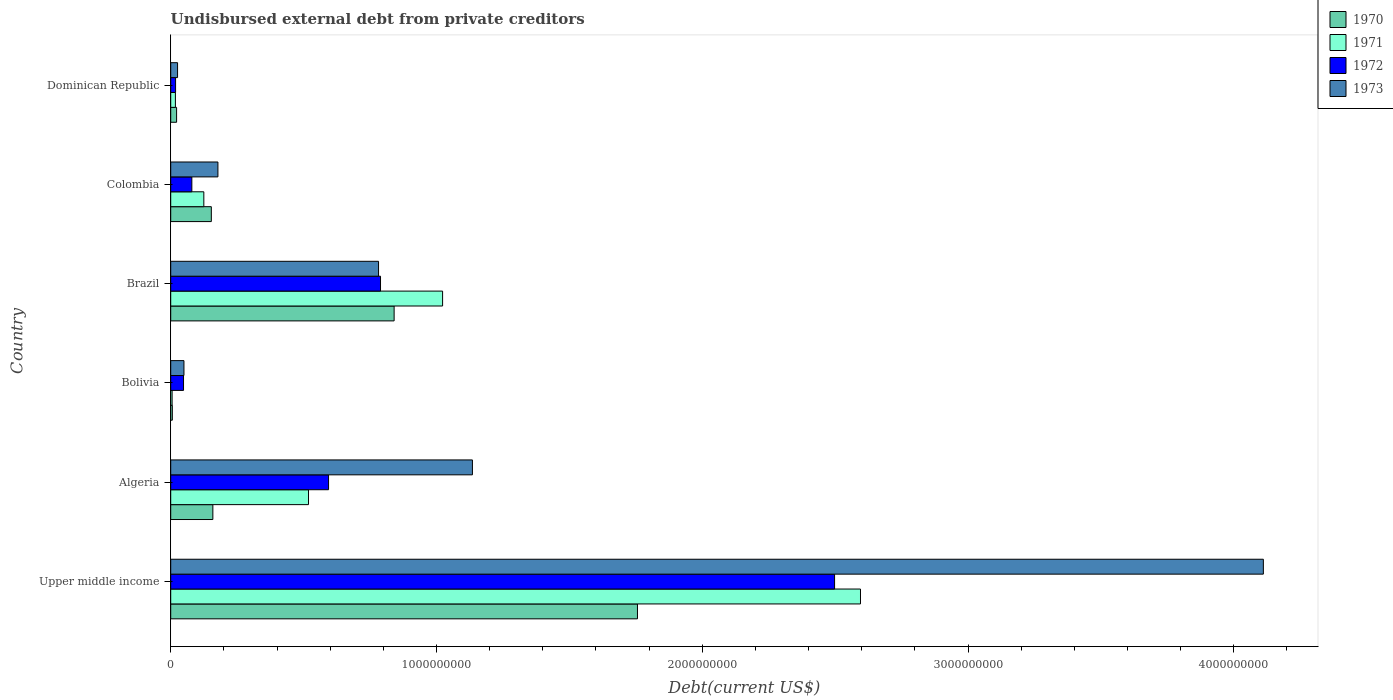How many different coloured bars are there?
Ensure brevity in your answer.  4. How many groups of bars are there?
Provide a succinct answer. 6. Are the number of bars per tick equal to the number of legend labels?
Offer a very short reply. Yes. Are the number of bars on each tick of the Y-axis equal?
Give a very brief answer. Yes. What is the label of the 6th group of bars from the top?
Your response must be concise. Upper middle income. What is the total debt in 1971 in Bolivia?
Your answer should be very brief. 5.25e+06. Across all countries, what is the maximum total debt in 1973?
Keep it short and to the point. 4.11e+09. Across all countries, what is the minimum total debt in 1973?
Provide a succinct answer. 2.58e+07. In which country was the total debt in 1971 maximum?
Ensure brevity in your answer.  Upper middle income. In which country was the total debt in 1972 minimum?
Your answer should be very brief. Dominican Republic. What is the total total debt in 1971 in the graph?
Ensure brevity in your answer.  4.28e+09. What is the difference between the total debt in 1971 in Brazil and that in Colombia?
Offer a terse response. 8.98e+08. What is the difference between the total debt in 1971 in Colombia and the total debt in 1970 in Algeria?
Keep it short and to the point. -3.40e+07. What is the average total debt in 1970 per country?
Offer a very short reply. 4.89e+08. What is the difference between the total debt in 1971 and total debt in 1973 in Brazil?
Keep it short and to the point. 2.41e+08. In how many countries, is the total debt in 1973 greater than 1800000000 US$?
Make the answer very short. 1. What is the ratio of the total debt in 1972 in Dominican Republic to that in Upper middle income?
Your answer should be compact. 0.01. Is the total debt in 1972 in Colombia less than that in Dominican Republic?
Ensure brevity in your answer.  No. What is the difference between the highest and the second highest total debt in 1970?
Offer a very short reply. 9.16e+08. What is the difference between the highest and the lowest total debt in 1973?
Your answer should be very brief. 4.09e+09. In how many countries, is the total debt in 1971 greater than the average total debt in 1971 taken over all countries?
Keep it short and to the point. 2. Is it the case that in every country, the sum of the total debt in 1972 and total debt in 1970 is greater than the sum of total debt in 1971 and total debt in 1973?
Offer a terse response. No. How many bars are there?
Make the answer very short. 24. Are all the bars in the graph horizontal?
Your answer should be compact. Yes. Are the values on the major ticks of X-axis written in scientific E-notation?
Ensure brevity in your answer.  No. Does the graph contain grids?
Keep it short and to the point. No. How many legend labels are there?
Keep it short and to the point. 4. How are the legend labels stacked?
Ensure brevity in your answer.  Vertical. What is the title of the graph?
Offer a very short reply. Undisbursed external debt from private creditors. What is the label or title of the X-axis?
Offer a very short reply. Debt(current US$). What is the Debt(current US$) in 1970 in Upper middle income?
Give a very brief answer. 1.76e+09. What is the Debt(current US$) in 1971 in Upper middle income?
Offer a very short reply. 2.60e+09. What is the Debt(current US$) in 1972 in Upper middle income?
Ensure brevity in your answer.  2.50e+09. What is the Debt(current US$) in 1973 in Upper middle income?
Offer a very short reply. 4.11e+09. What is the Debt(current US$) of 1970 in Algeria?
Provide a succinct answer. 1.59e+08. What is the Debt(current US$) of 1971 in Algeria?
Keep it short and to the point. 5.18e+08. What is the Debt(current US$) in 1972 in Algeria?
Make the answer very short. 5.94e+08. What is the Debt(current US$) in 1973 in Algeria?
Give a very brief answer. 1.14e+09. What is the Debt(current US$) in 1970 in Bolivia?
Your answer should be compact. 6.05e+06. What is the Debt(current US$) of 1971 in Bolivia?
Offer a terse response. 5.25e+06. What is the Debt(current US$) in 1972 in Bolivia?
Your answer should be compact. 4.82e+07. What is the Debt(current US$) of 1973 in Bolivia?
Provide a short and direct response. 4.98e+07. What is the Debt(current US$) of 1970 in Brazil?
Your response must be concise. 8.41e+08. What is the Debt(current US$) of 1971 in Brazil?
Give a very brief answer. 1.02e+09. What is the Debt(current US$) in 1972 in Brazil?
Your response must be concise. 7.89e+08. What is the Debt(current US$) in 1973 in Brazil?
Keep it short and to the point. 7.82e+08. What is the Debt(current US$) of 1970 in Colombia?
Offer a terse response. 1.53e+08. What is the Debt(current US$) in 1971 in Colombia?
Give a very brief answer. 1.25e+08. What is the Debt(current US$) in 1972 in Colombia?
Provide a succinct answer. 7.95e+07. What is the Debt(current US$) in 1973 in Colombia?
Provide a succinct answer. 1.78e+08. What is the Debt(current US$) of 1970 in Dominican Republic?
Give a very brief answer. 2.21e+07. What is the Debt(current US$) of 1971 in Dominican Republic?
Give a very brief answer. 1.76e+07. What is the Debt(current US$) in 1972 in Dominican Republic?
Provide a succinct answer. 1.83e+07. What is the Debt(current US$) of 1973 in Dominican Republic?
Offer a very short reply. 2.58e+07. Across all countries, what is the maximum Debt(current US$) of 1970?
Give a very brief answer. 1.76e+09. Across all countries, what is the maximum Debt(current US$) in 1971?
Give a very brief answer. 2.60e+09. Across all countries, what is the maximum Debt(current US$) of 1972?
Ensure brevity in your answer.  2.50e+09. Across all countries, what is the maximum Debt(current US$) in 1973?
Ensure brevity in your answer.  4.11e+09. Across all countries, what is the minimum Debt(current US$) of 1970?
Ensure brevity in your answer.  6.05e+06. Across all countries, what is the minimum Debt(current US$) of 1971?
Your answer should be very brief. 5.25e+06. Across all countries, what is the minimum Debt(current US$) of 1972?
Make the answer very short. 1.83e+07. Across all countries, what is the minimum Debt(current US$) of 1973?
Keep it short and to the point. 2.58e+07. What is the total Debt(current US$) of 1970 in the graph?
Your answer should be very brief. 2.94e+09. What is the total Debt(current US$) in 1971 in the graph?
Ensure brevity in your answer.  4.28e+09. What is the total Debt(current US$) of 1972 in the graph?
Provide a short and direct response. 4.03e+09. What is the total Debt(current US$) in 1973 in the graph?
Provide a short and direct response. 6.28e+09. What is the difference between the Debt(current US$) in 1970 in Upper middle income and that in Algeria?
Provide a short and direct response. 1.60e+09. What is the difference between the Debt(current US$) of 1971 in Upper middle income and that in Algeria?
Offer a very short reply. 2.08e+09. What is the difference between the Debt(current US$) in 1972 in Upper middle income and that in Algeria?
Provide a succinct answer. 1.90e+09. What is the difference between the Debt(current US$) in 1973 in Upper middle income and that in Algeria?
Your response must be concise. 2.98e+09. What is the difference between the Debt(current US$) in 1970 in Upper middle income and that in Bolivia?
Provide a succinct answer. 1.75e+09. What is the difference between the Debt(current US$) of 1971 in Upper middle income and that in Bolivia?
Offer a terse response. 2.59e+09. What is the difference between the Debt(current US$) in 1972 in Upper middle income and that in Bolivia?
Your answer should be very brief. 2.45e+09. What is the difference between the Debt(current US$) in 1973 in Upper middle income and that in Bolivia?
Give a very brief answer. 4.06e+09. What is the difference between the Debt(current US$) of 1970 in Upper middle income and that in Brazil?
Your answer should be very brief. 9.16e+08. What is the difference between the Debt(current US$) in 1971 in Upper middle income and that in Brazil?
Give a very brief answer. 1.57e+09. What is the difference between the Debt(current US$) in 1972 in Upper middle income and that in Brazil?
Make the answer very short. 1.71e+09. What is the difference between the Debt(current US$) of 1973 in Upper middle income and that in Brazil?
Your response must be concise. 3.33e+09. What is the difference between the Debt(current US$) of 1970 in Upper middle income and that in Colombia?
Offer a terse response. 1.60e+09. What is the difference between the Debt(current US$) of 1971 in Upper middle income and that in Colombia?
Make the answer very short. 2.47e+09. What is the difference between the Debt(current US$) of 1972 in Upper middle income and that in Colombia?
Keep it short and to the point. 2.42e+09. What is the difference between the Debt(current US$) of 1973 in Upper middle income and that in Colombia?
Your answer should be very brief. 3.93e+09. What is the difference between the Debt(current US$) in 1970 in Upper middle income and that in Dominican Republic?
Provide a short and direct response. 1.73e+09. What is the difference between the Debt(current US$) in 1971 in Upper middle income and that in Dominican Republic?
Your response must be concise. 2.58e+09. What is the difference between the Debt(current US$) of 1972 in Upper middle income and that in Dominican Republic?
Offer a terse response. 2.48e+09. What is the difference between the Debt(current US$) of 1973 in Upper middle income and that in Dominican Republic?
Give a very brief answer. 4.09e+09. What is the difference between the Debt(current US$) in 1970 in Algeria and that in Bolivia?
Offer a terse response. 1.53e+08. What is the difference between the Debt(current US$) in 1971 in Algeria and that in Bolivia?
Provide a short and direct response. 5.13e+08. What is the difference between the Debt(current US$) in 1972 in Algeria and that in Bolivia?
Give a very brief answer. 5.46e+08. What is the difference between the Debt(current US$) of 1973 in Algeria and that in Bolivia?
Provide a succinct answer. 1.09e+09. What is the difference between the Debt(current US$) of 1970 in Algeria and that in Brazil?
Offer a very short reply. -6.82e+08. What is the difference between the Debt(current US$) of 1971 in Algeria and that in Brazil?
Keep it short and to the point. -5.05e+08. What is the difference between the Debt(current US$) in 1972 in Algeria and that in Brazil?
Provide a short and direct response. -1.95e+08. What is the difference between the Debt(current US$) of 1973 in Algeria and that in Brazil?
Provide a short and direct response. 3.53e+08. What is the difference between the Debt(current US$) of 1970 in Algeria and that in Colombia?
Your answer should be very brief. 5.77e+06. What is the difference between the Debt(current US$) in 1971 in Algeria and that in Colombia?
Offer a very short reply. 3.94e+08. What is the difference between the Debt(current US$) in 1972 in Algeria and that in Colombia?
Your response must be concise. 5.14e+08. What is the difference between the Debt(current US$) in 1973 in Algeria and that in Colombia?
Your response must be concise. 9.58e+08. What is the difference between the Debt(current US$) of 1970 in Algeria and that in Dominican Republic?
Your response must be concise. 1.36e+08. What is the difference between the Debt(current US$) in 1971 in Algeria and that in Dominican Republic?
Make the answer very short. 5.01e+08. What is the difference between the Debt(current US$) in 1972 in Algeria and that in Dominican Republic?
Your answer should be very brief. 5.76e+08. What is the difference between the Debt(current US$) in 1973 in Algeria and that in Dominican Republic?
Keep it short and to the point. 1.11e+09. What is the difference between the Debt(current US$) in 1970 in Bolivia and that in Brazil?
Provide a succinct answer. -8.35e+08. What is the difference between the Debt(current US$) of 1971 in Bolivia and that in Brazil?
Offer a terse response. -1.02e+09. What is the difference between the Debt(current US$) in 1972 in Bolivia and that in Brazil?
Give a very brief answer. -7.41e+08. What is the difference between the Debt(current US$) of 1973 in Bolivia and that in Brazil?
Offer a very short reply. -7.32e+08. What is the difference between the Debt(current US$) in 1970 in Bolivia and that in Colombia?
Your answer should be compact. -1.47e+08. What is the difference between the Debt(current US$) of 1971 in Bolivia and that in Colombia?
Provide a succinct answer. -1.19e+08. What is the difference between the Debt(current US$) of 1972 in Bolivia and that in Colombia?
Your response must be concise. -3.13e+07. What is the difference between the Debt(current US$) of 1973 in Bolivia and that in Colombia?
Your response must be concise. -1.28e+08. What is the difference between the Debt(current US$) of 1970 in Bolivia and that in Dominican Republic?
Provide a succinct answer. -1.60e+07. What is the difference between the Debt(current US$) of 1971 in Bolivia and that in Dominican Republic?
Offer a terse response. -1.24e+07. What is the difference between the Debt(current US$) of 1972 in Bolivia and that in Dominican Republic?
Give a very brief answer. 2.99e+07. What is the difference between the Debt(current US$) of 1973 in Bolivia and that in Dominican Republic?
Keep it short and to the point. 2.40e+07. What is the difference between the Debt(current US$) of 1970 in Brazil and that in Colombia?
Offer a terse response. 6.88e+08. What is the difference between the Debt(current US$) of 1971 in Brazil and that in Colombia?
Provide a succinct answer. 8.98e+08. What is the difference between the Debt(current US$) in 1972 in Brazil and that in Colombia?
Offer a terse response. 7.10e+08. What is the difference between the Debt(current US$) in 1973 in Brazil and that in Colombia?
Offer a terse response. 6.04e+08. What is the difference between the Debt(current US$) of 1970 in Brazil and that in Dominican Republic?
Provide a succinct answer. 8.19e+08. What is the difference between the Debt(current US$) of 1971 in Brazil and that in Dominican Republic?
Offer a terse response. 1.01e+09. What is the difference between the Debt(current US$) in 1972 in Brazil and that in Dominican Republic?
Ensure brevity in your answer.  7.71e+08. What is the difference between the Debt(current US$) of 1973 in Brazil and that in Dominican Republic?
Provide a succinct answer. 7.56e+08. What is the difference between the Debt(current US$) of 1970 in Colombia and that in Dominican Republic?
Your response must be concise. 1.31e+08. What is the difference between the Debt(current US$) in 1971 in Colombia and that in Dominican Republic?
Your response must be concise. 1.07e+08. What is the difference between the Debt(current US$) of 1972 in Colombia and that in Dominican Republic?
Offer a terse response. 6.12e+07. What is the difference between the Debt(current US$) in 1973 in Colombia and that in Dominican Republic?
Make the answer very short. 1.52e+08. What is the difference between the Debt(current US$) in 1970 in Upper middle income and the Debt(current US$) in 1971 in Algeria?
Your response must be concise. 1.24e+09. What is the difference between the Debt(current US$) in 1970 in Upper middle income and the Debt(current US$) in 1972 in Algeria?
Give a very brief answer. 1.16e+09. What is the difference between the Debt(current US$) of 1970 in Upper middle income and the Debt(current US$) of 1973 in Algeria?
Offer a very short reply. 6.21e+08. What is the difference between the Debt(current US$) in 1971 in Upper middle income and the Debt(current US$) in 1972 in Algeria?
Your response must be concise. 2.00e+09. What is the difference between the Debt(current US$) in 1971 in Upper middle income and the Debt(current US$) in 1973 in Algeria?
Offer a terse response. 1.46e+09. What is the difference between the Debt(current US$) in 1972 in Upper middle income and the Debt(current US$) in 1973 in Algeria?
Keep it short and to the point. 1.36e+09. What is the difference between the Debt(current US$) in 1970 in Upper middle income and the Debt(current US$) in 1971 in Bolivia?
Provide a short and direct response. 1.75e+09. What is the difference between the Debt(current US$) of 1970 in Upper middle income and the Debt(current US$) of 1972 in Bolivia?
Your response must be concise. 1.71e+09. What is the difference between the Debt(current US$) in 1970 in Upper middle income and the Debt(current US$) in 1973 in Bolivia?
Give a very brief answer. 1.71e+09. What is the difference between the Debt(current US$) of 1971 in Upper middle income and the Debt(current US$) of 1972 in Bolivia?
Offer a terse response. 2.55e+09. What is the difference between the Debt(current US$) of 1971 in Upper middle income and the Debt(current US$) of 1973 in Bolivia?
Your response must be concise. 2.55e+09. What is the difference between the Debt(current US$) of 1972 in Upper middle income and the Debt(current US$) of 1973 in Bolivia?
Give a very brief answer. 2.45e+09. What is the difference between the Debt(current US$) in 1970 in Upper middle income and the Debt(current US$) in 1971 in Brazil?
Keep it short and to the point. 7.33e+08. What is the difference between the Debt(current US$) of 1970 in Upper middle income and the Debt(current US$) of 1972 in Brazil?
Your response must be concise. 9.67e+08. What is the difference between the Debt(current US$) of 1970 in Upper middle income and the Debt(current US$) of 1973 in Brazil?
Give a very brief answer. 9.74e+08. What is the difference between the Debt(current US$) of 1971 in Upper middle income and the Debt(current US$) of 1972 in Brazil?
Offer a very short reply. 1.81e+09. What is the difference between the Debt(current US$) of 1971 in Upper middle income and the Debt(current US$) of 1973 in Brazil?
Give a very brief answer. 1.81e+09. What is the difference between the Debt(current US$) of 1972 in Upper middle income and the Debt(current US$) of 1973 in Brazil?
Keep it short and to the point. 1.72e+09. What is the difference between the Debt(current US$) of 1970 in Upper middle income and the Debt(current US$) of 1971 in Colombia?
Your response must be concise. 1.63e+09. What is the difference between the Debt(current US$) in 1970 in Upper middle income and the Debt(current US$) in 1972 in Colombia?
Keep it short and to the point. 1.68e+09. What is the difference between the Debt(current US$) of 1970 in Upper middle income and the Debt(current US$) of 1973 in Colombia?
Offer a very short reply. 1.58e+09. What is the difference between the Debt(current US$) of 1971 in Upper middle income and the Debt(current US$) of 1972 in Colombia?
Your answer should be very brief. 2.52e+09. What is the difference between the Debt(current US$) in 1971 in Upper middle income and the Debt(current US$) in 1973 in Colombia?
Your response must be concise. 2.42e+09. What is the difference between the Debt(current US$) in 1972 in Upper middle income and the Debt(current US$) in 1973 in Colombia?
Offer a terse response. 2.32e+09. What is the difference between the Debt(current US$) of 1970 in Upper middle income and the Debt(current US$) of 1971 in Dominican Republic?
Your answer should be very brief. 1.74e+09. What is the difference between the Debt(current US$) in 1970 in Upper middle income and the Debt(current US$) in 1972 in Dominican Republic?
Provide a short and direct response. 1.74e+09. What is the difference between the Debt(current US$) of 1970 in Upper middle income and the Debt(current US$) of 1973 in Dominican Republic?
Ensure brevity in your answer.  1.73e+09. What is the difference between the Debt(current US$) of 1971 in Upper middle income and the Debt(current US$) of 1972 in Dominican Republic?
Provide a succinct answer. 2.58e+09. What is the difference between the Debt(current US$) of 1971 in Upper middle income and the Debt(current US$) of 1973 in Dominican Republic?
Ensure brevity in your answer.  2.57e+09. What is the difference between the Debt(current US$) of 1972 in Upper middle income and the Debt(current US$) of 1973 in Dominican Republic?
Offer a terse response. 2.47e+09. What is the difference between the Debt(current US$) in 1970 in Algeria and the Debt(current US$) in 1971 in Bolivia?
Keep it short and to the point. 1.53e+08. What is the difference between the Debt(current US$) in 1970 in Algeria and the Debt(current US$) in 1972 in Bolivia?
Offer a very short reply. 1.10e+08. What is the difference between the Debt(current US$) in 1970 in Algeria and the Debt(current US$) in 1973 in Bolivia?
Provide a succinct answer. 1.09e+08. What is the difference between the Debt(current US$) of 1971 in Algeria and the Debt(current US$) of 1972 in Bolivia?
Keep it short and to the point. 4.70e+08. What is the difference between the Debt(current US$) of 1971 in Algeria and the Debt(current US$) of 1973 in Bolivia?
Make the answer very short. 4.69e+08. What is the difference between the Debt(current US$) of 1972 in Algeria and the Debt(current US$) of 1973 in Bolivia?
Keep it short and to the point. 5.44e+08. What is the difference between the Debt(current US$) in 1970 in Algeria and the Debt(current US$) in 1971 in Brazil?
Provide a succinct answer. -8.64e+08. What is the difference between the Debt(current US$) in 1970 in Algeria and the Debt(current US$) in 1972 in Brazil?
Provide a succinct answer. -6.31e+08. What is the difference between the Debt(current US$) of 1970 in Algeria and the Debt(current US$) of 1973 in Brazil?
Your answer should be compact. -6.23e+08. What is the difference between the Debt(current US$) of 1971 in Algeria and the Debt(current US$) of 1972 in Brazil?
Provide a short and direct response. -2.71e+08. What is the difference between the Debt(current US$) of 1971 in Algeria and the Debt(current US$) of 1973 in Brazil?
Provide a short and direct response. -2.64e+08. What is the difference between the Debt(current US$) of 1972 in Algeria and the Debt(current US$) of 1973 in Brazil?
Your response must be concise. -1.88e+08. What is the difference between the Debt(current US$) in 1970 in Algeria and the Debt(current US$) in 1971 in Colombia?
Make the answer very short. 3.40e+07. What is the difference between the Debt(current US$) in 1970 in Algeria and the Debt(current US$) in 1972 in Colombia?
Keep it short and to the point. 7.91e+07. What is the difference between the Debt(current US$) of 1970 in Algeria and the Debt(current US$) of 1973 in Colombia?
Provide a short and direct response. -1.90e+07. What is the difference between the Debt(current US$) in 1971 in Algeria and the Debt(current US$) in 1972 in Colombia?
Your answer should be compact. 4.39e+08. What is the difference between the Debt(current US$) in 1971 in Algeria and the Debt(current US$) in 1973 in Colombia?
Your answer should be very brief. 3.41e+08. What is the difference between the Debt(current US$) of 1972 in Algeria and the Debt(current US$) of 1973 in Colombia?
Offer a terse response. 4.16e+08. What is the difference between the Debt(current US$) in 1970 in Algeria and the Debt(current US$) in 1971 in Dominican Republic?
Your answer should be compact. 1.41e+08. What is the difference between the Debt(current US$) of 1970 in Algeria and the Debt(current US$) of 1972 in Dominican Republic?
Keep it short and to the point. 1.40e+08. What is the difference between the Debt(current US$) in 1970 in Algeria and the Debt(current US$) in 1973 in Dominican Republic?
Keep it short and to the point. 1.33e+08. What is the difference between the Debt(current US$) of 1971 in Algeria and the Debt(current US$) of 1972 in Dominican Republic?
Your answer should be compact. 5.00e+08. What is the difference between the Debt(current US$) of 1971 in Algeria and the Debt(current US$) of 1973 in Dominican Republic?
Give a very brief answer. 4.93e+08. What is the difference between the Debt(current US$) of 1972 in Algeria and the Debt(current US$) of 1973 in Dominican Republic?
Your answer should be compact. 5.68e+08. What is the difference between the Debt(current US$) of 1970 in Bolivia and the Debt(current US$) of 1971 in Brazil?
Make the answer very short. -1.02e+09. What is the difference between the Debt(current US$) in 1970 in Bolivia and the Debt(current US$) in 1972 in Brazil?
Offer a very short reply. -7.83e+08. What is the difference between the Debt(current US$) of 1970 in Bolivia and the Debt(current US$) of 1973 in Brazil?
Ensure brevity in your answer.  -7.76e+08. What is the difference between the Debt(current US$) in 1971 in Bolivia and the Debt(current US$) in 1972 in Brazil?
Make the answer very short. -7.84e+08. What is the difference between the Debt(current US$) in 1971 in Bolivia and the Debt(current US$) in 1973 in Brazil?
Provide a succinct answer. -7.77e+08. What is the difference between the Debt(current US$) in 1972 in Bolivia and the Debt(current US$) in 1973 in Brazil?
Offer a very short reply. -7.34e+08. What is the difference between the Debt(current US$) of 1970 in Bolivia and the Debt(current US$) of 1971 in Colombia?
Offer a terse response. -1.19e+08. What is the difference between the Debt(current US$) of 1970 in Bolivia and the Debt(current US$) of 1972 in Colombia?
Provide a short and direct response. -7.34e+07. What is the difference between the Debt(current US$) in 1970 in Bolivia and the Debt(current US$) in 1973 in Colombia?
Provide a succinct answer. -1.72e+08. What is the difference between the Debt(current US$) in 1971 in Bolivia and the Debt(current US$) in 1972 in Colombia?
Make the answer very short. -7.42e+07. What is the difference between the Debt(current US$) of 1971 in Bolivia and the Debt(current US$) of 1973 in Colombia?
Ensure brevity in your answer.  -1.72e+08. What is the difference between the Debt(current US$) of 1972 in Bolivia and the Debt(current US$) of 1973 in Colombia?
Provide a succinct answer. -1.29e+08. What is the difference between the Debt(current US$) of 1970 in Bolivia and the Debt(current US$) of 1971 in Dominican Republic?
Give a very brief answer. -1.16e+07. What is the difference between the Debt(current US$) of 1970 in Bolivia and the Debt(current US$) of 1972 in Dominican Republic?
Give a very brief answer. -1.23e+07. What is the difference between the Debt(current US$) of 1970 in Bolivia and the Debt(current US$) of 1973 in Dominican Republic?
Give a very brief answer. -1.97e+07. What is the difference between the Debt(current US$) in 1971 in Bolivia and the Debt(current US$) in 1972 in Dominican Republic?
Make the answer very short. -1.31e+07. What is the difference between the Debt(current US$) of 1971 in Bolivia and the Debt(current US$) of 1973 in Dominican Republic?
Provide a short and direct response. -2.05e+07. What is the difference between the Debt(current US$) of 1972 in Bolivia and the Debt(current US$) of 1973 in Dominican Republic?
Give a very brief answer. 2.24e+07. What is the difference between the Debt(current US$) in 1970 in Brazil and the Debt(current US$) in 1971 in Colombia?
Offer a very short reply. 7.16e+08. What is the difference between the Debt(current US$) in 1970 in Brazil and the Debt(current US$) in 1972 in Colombia?
Offer a very short reply. 7.61e+08. What is the difference between the Debt(current US$) of 1970 in Brazil and the Debt(current US$) of 1973 in Colombia?
Keep it short and to the point. 6.63e+08. What is the difference between the Debt(current US$) in 1971 in Brazil and the Debt(current US$) in 1972 in Colombia?
Offer a terse response. 9.44e+08. What is the difference between the Debt(current US$) of 1971 in Brazil and the Debt(current US$) of 1973 in Colombia?
Provide a short and direct response. 8.45e+08. What is the difference between the Debt(current US$) in 1972 in Brazil and the Debt(current US$) in 1973 in Colombia?
Keep it short and to the point. 6.12e+08. What is the difference between the Debt(current US$) in 1970 in Brazil and the Debt(current US$) in 1971 in Dominican Republic?
Provide a succinct answer. 8.23e+08. What is the difference between the Debt(current US$) in 1970 in Brazil and the Debt(current US$) in 1972 in Dominican Republic?
Ensure brevity in your answer.  8.22e+08. What is the difference between the Debt(current US$) of 1970 in Brazil and the Debt(current US$) of 1973 in Dominican Republic?
Provide a succinct answer. 8.15e+08. What is the difference between the Debt(current US$) in 1971 in Brazil and the Debt(current US$) in 1972 in Dominican Republic?
Offer a terse response. 1.00e+09. What is the difference between the Debt(current US$) in 1971 in Brazil and the Debt(current US$) in 1973 in Dominican Republic?
Your response must be concise. 9.97e+08. What is the difference between the Debt(current US$) of 1972 in Brazil and the Debt(current US$) of 1973 in Dominican Republic?
Ensure brevity in your answer.  7.64e+08. What is the difference between the Debt(current US$) of 1970 in Colombia and the Debt(current US$) of 1971 in Dominican Republic?
Your answer should be compact. 1.35e+08. What is the difference between the Debt(current US$) in 1970 in Colombia and the Debt(current US$) in 1972 in Dominican Republic?
Provide a succinct answer. 1.34e+08. What is the difference between the Debt(current US$) of 1970 in Colombia and the Debt(current US$) of 1973 in Dominican Republic?
Offer a very short reply. 1.27e+08. What is the difference between the Debt(current US$) of 1971 in Colombia and the Debt(current US$) of 1972 in Dominican Republic?
Provide a succinct answer. 1.06e+08. What is the difference between the Debt(current US$) of 1971 in Colombia and the Debt(current US$) of 1973 in Dominican Republic?
Make the answer very short. 9.88e+07. What is the difference between the Debt(current US$) of 1972 in Colombia and the Debt(current US$) of 1973 in Dominican Republic?
Offer a terse response. 5.37e+07. What is the average Debt(current US$) in 1970 per country?
Your answer should be very brief. 4.89e+08. What is the average Debt(current US$) of 1971 per country?
Offer a terse response. 7.14e+08. What is the average Debt(current US$) of 1972 per country?
Offer a very short reply. 6.71e+08. What is the average Debt(current US$) of 1973 per country?
Offer a terse response. 1.05e+09. What is the difference between the Debt(current US$) of 1970 and Debt(current US$) of 1971 in Upper middle income?
Your answer should be compact. -8.39e+08. What is the difference between the Debt(current US$) in 1970 and Debt(current US$) in 1972 in Upper middle income?
Your response must be concise. -7.42e+08. What is the difference between the Debt(current US$) in 1970 and Debt(current US$) in 1973 in Upper middle income?
Keep it short and to the point. -2.36e+09. What is the difference between the Debt(current US$) in 1971 and Debt(current US$) in 1972 in Upper middle income?
Your answer should be compact. 9.75e+07. What is the difference between the Debt(current US$) of 1971 and Debt(current US$) of 1973 in Upper middle income?
Provide a short and direct response. -1.52e+09. What is the difference between the Debt(current US$) in 1972 and Debt(current US$) in 1973 in Upper middle income?
Provide a succinct answer. -1.61e+09. What is the difference between the Debt(current US$) of 1970 and Debt(current US$) of 1971 in Algeria?
Ensure brevity in your answer.  -3.60e+08. What is the difference between the Debt(current US$) in 1970 and Debt(current US$) in 1972 in Algeria?
Keep it short and to the point. -4.35e+08. What is the difference between the Debt(current US$) in 1970 and Debt(current US$) in 1973 in Algeria?
Ensure brevity in your answer.  -9.77e+08. What is the difference between the Debt(current US$) in 1971 and Debt(current US$) in 1972 in Algeria?
Your answer should be very brief. -7.55e+07. What is the difference between the Debt(current US$) in 1971 and Debt(current US$) in 1973 in Algeria?
Ensure brevity in your answer.  -6.17e+08. What is the difference between the Debt(current US$) in 1972 and Debt(current US$) in 1973 in Algeria?
Offer a terse response. -5.41e+08. What is the difference between the Debt(current US$) of 1970 and Debt(current US$) of 1971 in Bolivia?
Offer a very short reply. 8.02e+05. What is the difference between the Debt(current US$) of 1970 and Debt(current US$) of 1972 in Bolivia?
Your answer should be very brief. -4.22e+07. What is the difference between the Debt(current US$) in 1970 and Debt(current US$) in 1973 in Bolivia?
Offer a very short reply. -4.37e+07. What is the difference between the Debt(current US$) of 1971 and Debt(current US$) of 1972 in Bolivia?
Provide a succinct answer. -4.30e+07. What is the difference between the Debt(current US$) in 1971 and Debt(current US$) in 1973 in Bolivia?
Keep it short and to the point. -4.45e+07. What is the difference between the Debt(current US$) of 1972 and Debt(current US$) of 1973 in Bolivia?
Provide a succinct answer. -1.58e+06. What is the difference between the Debt(current US$) of 1970 and Debt(current US$) of 1971 in Brazil?
Offer a very short reply. -1.82e+08. What is the difference between the Debt(current US$) of 1970 and Debt(current US$) of 1972 in Brazil?
Provide a short and direct response. 5.12e+07. What is the difference between the Debt(current US$) of 1970 and Debt(current US$) of 1973 in Brazil?
Your answer should be compact. 5.86e+07. What is the difference between the Debt(current US$) in 1971 and Debt(current US$) in 1972 in Brazil?
Your response must be concise. 2.34e+08. What is the difference between the Debt(current US$) in 1971 and Debt(current US$) in 1973 in Brazil?
Keep it short and to the point. 2.41e+08. What is the difference between the Debt(current US$) in 1972 and Debt(current US$) in 1973 in Brazil?
Give a very brief answer. 7.41e+06. What is the difference between the Debt(current US$) of 1970 and Debt(current US$) of 1971 in Colombia?
Offer a very short reply. 2.82e+07. What is the difference between the Debt(current US$) in 1970 and Debt(current US$) in 1972 in Colombia?
Provide a short and direct response. 7.33e+07. What is the difference between the Debt(current US$) of 1970 and Debt(current US$) of 1973 in Colombia?
Keep it short and to the point. -2.48e+07. What is the difference between the Debt(current US$) in 1971 and Debt(current US$) in 1972 in Colombia?
Give a very brief answer. 4.51e+07. What is the difference between the Debt(current US$) in 1971 and Debt(current US$) in 1973 in Colombia?
Ensure brevity in your answer.  -5.30e+07. What is the difference between the Debt(current US$) of 1972 and Debt(current US$) of 1973 in Colombia?
Offer a terse response. -9.81e+07. What is the difference between the Debt(current US$) of 1970 and Debt(current US$) of 1971 in Dominican Republic?
Your answer should be compact. 4.46e+06. What is the difference between the Debt(current US$) in 1970 and Debt(current US$) in 1972 in Dominican Republic?
Your answer should be compact. 3.78e+06. What is the difference between the Debt(current US$) of 1970 and Debt(current US$) of 1973 in Dominican Republic?
Your answer should be compact. -3.68e+06. What is the difference between the Debt(current US$) of 1971 and Debt(current US$) of 1972 in Dominican Republic?
Provide a short and direct response. -6.84e+05. What is the difference between the Debt(current US$) of 1971 and Debt(current US$) of 1973 in Dominican Republic?
Ensure brevity in your answer.  -8.14e+06. What is the difference between the Debt(current US$) of 1972 and Debt(current US$) of 1973 in Dominican Republic?
Provide a succinct answer. -7.46e+06. What is the ratio of the Debt(current US$) of 1970 in Upper middle income to that in Algeria?
Your response must be concise. 11.08. What is the ratio of the Debt(current US$) in 1971 in Upper middle income to that in Algeria?
Keep it short and to the point. 5.01. What is the ratio of the Debt(current US$) of 1972 in Upper middle income to that in Algeria?
Your answer should be compact. 4.21. What is the ratio of the Debt(current US$) in 1973 in Upper middle income to that in Algeria?
Your answer should be compact. 3.62. What is the ratio of the Debt(current US$) in 1970 in Upper middle income to that in Bolivia?
Your answer should be compact. 290.38. What is the ratio of the Debt(current US$) of 1971 in Upper middle income to that in Bolivia?
Your response must be concise. 494.74. What is the ratio of the Debt(current US$) of 1972 in Upper middle income to that in Bolivia?
Provide a succinct answer. 51.81. What is the ratio of the Debt(current US$) in 1973 in Upper middle income to that in Bolivia?
Your response must be concise. 82.58. What is the ratio of the Debt(current US$) in 1970 in Upper middle income to that in Brazil?
Your answer should be compact. 2.09. What is the ratio of the Debt(current US$) of 1971 in Upper middle income to that in Brazil?
Provide a succinct answer. 2.54. What is the ratio of the Debt(current US$) in 1972 in Upper middle income to that in Brazil?
Keep it short and to the point. 3.16. What is the ratio of the Debt(current US$) of 1973 in Upper middle income to that in Brazil?
Give a very brief answer. 5.26. What is the ratio of the Debt(current US$) of 1970 in Upper middle income to that in Colombia?
Keep it short and to the point. 11.49. What is the ratio of the Debt(current US$) of 1971 in Upper middle income to that in Colombia?
Make the answer very short. 20.83. What is the ratio of the Debt(current US$) of 1972 in Upper middle income to that in Colombia?
Keep it short and to the point. 31.43. What is the ratio of the Debt(current US$) in 1973 in Upper middle income to that in Colombia?
Your answer should be very brief. 23.15. What is the ratio of the Debt(current US$) of 1970 in Upper middle income to that in Dominican Republic?
Make the answer very short. 79.48. What is the ratio of the Debt(current US$) in 1971 in Upper middle income to that in Dominican Republic?
Ensure brevity in your answer.  147.2. What is the ratio of the Debt(current US$) in 1972 in Upper middle income to that in Dominican Republic?
Your answer should be very brief. 136.38. What is the ratio of the Debt(current US$) of 1973 in Upper middle income to that in Dominican Republic?
Your answer should be very brief. 159.52. What is the ratio of the Debt(current US$) in 1970 in Algeria to that in Bolivia?
Keep it short and to the point. 26.22. What is the ratio of the Debt(current US$) in 1971 in Algeria to that in Bolivia?
Keep it short and to the point. 98.83. What is the ratio of the Debt(current US$) in 1972 in Algeria to that in Bolivia?
Offer a terse response. 12.32. What is the ratio of the Debt(current US$) of 1973 in Algeria to that in Bolivia?
Give a very brief answer. 22.8. What is the ratio of the Debt(current US$) of 1970 in Algeria to that in Brazil?
Your answer should be compact. 0.19. What is the ratio of the Debt(current US$) in 1971 in Algeria to that in Brazil?
Make the answer very short. 0.51. What is the ratio of the Debt(current US$) in 1972 in Algeria to that in Brazil?
Give a very brief answer. 0.75. What is the ratio of the Debt(current US$) of 1973 in Algeria to that in Brazil?
Your answer should be compact. 1.45. What is the ratio of the Debt(current US$) of 1970 in Algeria to that in Colombia?
Your answer should be very brief. 1.04. What is the ratio of the Debt(current US$) in 1971 in Algeria to that in Colombia?
Make the answer very short. 4.16. What is the ratio of the Debt(current US$) in 1972 in Algeria to that in Colombia?
Provide a succinct answer. 7.47. What is the ratio of the Debt(current US$) of 1973 in Algeria to that in Colombia?
Provide a short and direct response. 6.39. What is the ratio of the Debt(current US$) of 1970 in Algeria to that in Dominican Republic?
Your answer should be very brief. 7.18. What is the ratio of the Debt(current US$) of 1971 in Algeria to that in Dominican Republic?
Provide a short and direct response. 29.4. What is the ratio of the Debt(current US$) of 1972 in Algeria to that in Dominican Republic?
Offer a very short reply. 32.43. What is the ratio of the Debt(current US$) of 1973 in Algeria to that in Dominican Republic?
Offer a terse response. 44.05. What is the ratio of the Debt(current US$) of 1970 in Bolivia to that in Brazil?
Ensure brevity in your answer.  0.01. What is the ratio of the Debt(current US$) of 1971 in Bolivia to that in Brazil?
Your response must be concise. 0.01. What is the ratio of the Debt(current US$) of 1972 in Bolivia to that in Brazil?
Provide a short and direct response. 0.06. What is the ratio of the Debt(current US$) in 1973 in Bolivia to that in Brazil?
Offer a very short reply. 0.06. What is the ratio of the Debt(current US$) of 1970 in Bolivia to that in Colombia?
Your answer should be very brief. 0.04. What is the ratio of the Debt(current US$) in 1971 in Bolivia to that in Colombia?
Offer a terse response. 0.04. What is the ratio of the Debt(current US$) in 1972 in Bolivia to that in Colombia?
Provide a succinct answer. 0.61. What is the ratio of the Debt(current US$) in 1973 in Bolivia to that in Colombia?
Give a very brief answer. 0.28. What is the ratio of the Debt(current US$) of 1970 in Bolivia to that in Dominican Republic?
Provide a succinct answer. 0.27. What is the ratio of the Debt(current US$) of 1971 in Bolivia to that in Dominican Republic?
Offer a very short reply. 0.3. What is the ratio of the Debt(current US$) in 1972 in Bolivia to that in Dominican Republic?
Keep it short and to the point. 2.63. What is the ratio of the Debt(current US$) of 1973 in Bolivia to that in Dominican Republic?
Make the answer very short. 1.93. What is the ratio of the Debt(current US$) of 1970 in Brazil to that in Colombia?
Provide a succinct answer. 5.5. What is the ratio of the Debt(current US$) of 1971 in Brazil to that in Colombia?
Offer a terse response. 8.21. What is the ratio of the Debt(current US$) of 1972 in Brazil to that in Colombia?
Make the answer very short. 9.93. What is the ratio of the Debt(current US$) of 1973 in Brazil to that in Colombia?
Offer a very short reply. 4.4. What is the ratio of the Debt(current US$) of 1970 in Brazil to that in Dominican Republic?
Your answer should be compact. 38.04. What is the ratio of the Debt(current US$) of 1971 in Brazil to that in Dominican Republic?
Provide a succinct answer. 58.02. What is the ratio of the Debt(current US$) in 1972 in Brazil to that in Dominican Republic?
Your response must be concise. 43.1. What is the ratio of the Debt(current US$) of 1973 in Brazil to that in Dominican Republic?
Your answer should be compact. 30.34. What is the ratio of the Debt(current US$) in 1970 in Colombia to that in Dominican Republic?
Keep it short and to the point. 6.92. What is the ratio of the Debt(current US$) of 1971 in Colombia to that in Dominican Republic?
Provide a succinct answer. 7.07. What is the ratio of the Debt(current US$) of 1972 in Colombia to that in Dominican Republic?
Make the answer very short. 4.34. What is the ratio of the Debt(current US$) of 1973 in Colombia to that in Dominican Republic?
Your answer should be very brief. 6.89. What is the difference between the highest and the second highest Debt(current US$) in 1970?
Your answer should be very brief. 9.16e+08. What is the difference between the highest and the second highest Debt(current US$) in 1971?
Your answer should be compact. 1.57e+09. What is the difference between the highest and the second highest Debt(current US$) in 1972?
Offer a terse response. 1.71e+09. What is the difference between the highest and the second highest Debt(current US$) of 1973?
Ensure brevity in your answer.  2.98e+09. What is the difference between the highest and the lowest Debt(current US$) of 1970?
Offer a very short reply. 1.75e+09. What is the difference between the highest and the lowest Debt(current US$) of 1971?
Your answer should be compact. 2.59e+09. What is the difference between the highest and the lowest Debt(current US$) of 1972?
Ensure brevity in your answer.  2.48e+09. What is the difference between the highest and the lowest Debt(current US$) of 1973?
Provide a succinct answer. 4.09e+09. 